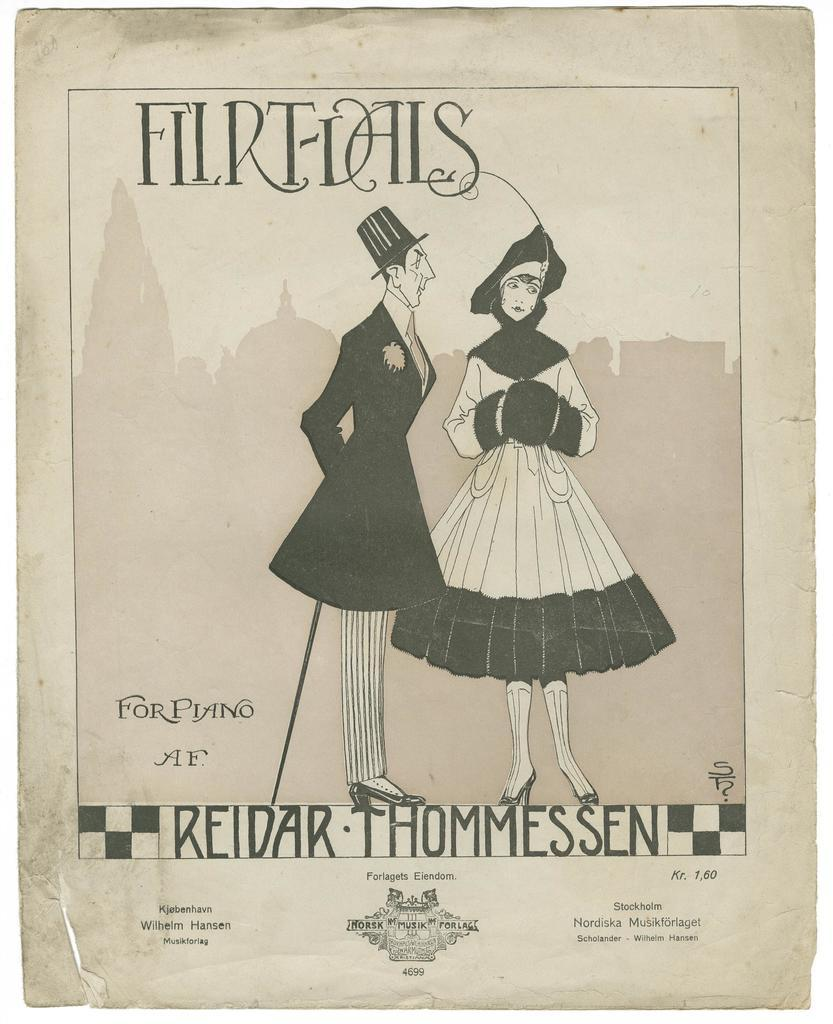What is the main subject of the poster in the image? The poster contains a black and white picture of a man standing beside a woman. Where is the text located in relation to the picture on the poster? There is text above and below the picture on the poster. How many holes can be seen in the tooth depicted in the image? There is no tooth or hole present in the image; it features a poster with a picture of a man and woman. 